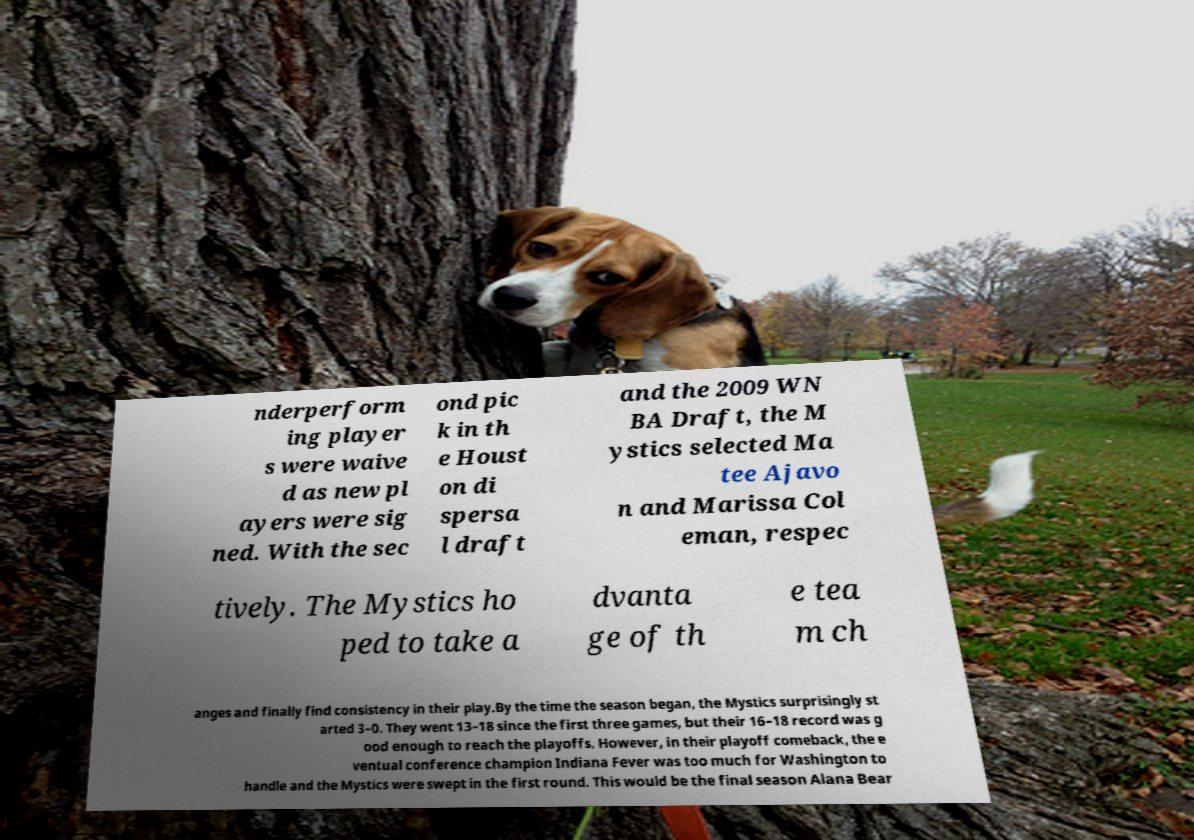What messages or text are displayed in this image? I need them in a readable, typed format. nderperform ing player s were waive d as new pl ayers were sig ned. With the sec ond pic k in th e Houst on di spersa l draft and the 2009 WN BA Draft, the M ystics selected Ma tee Ajavo n and Marissa Col eman, respec tively. The Mystics ho ped to take a dvanta ge of th e tea m ch anges and finally find consistency in their play.By the time the season began, the Mystics surprisingly st arted 3–0. They went 13–18 since the first three games, but their 16–18 record was g ood enough to reach the playoffs. However, in their playoff comeback, the e ventual conference champion Indiana Fever was too much for Washington to handle and the Mystics were swept in the first round. This would be the final season Alana Bear 